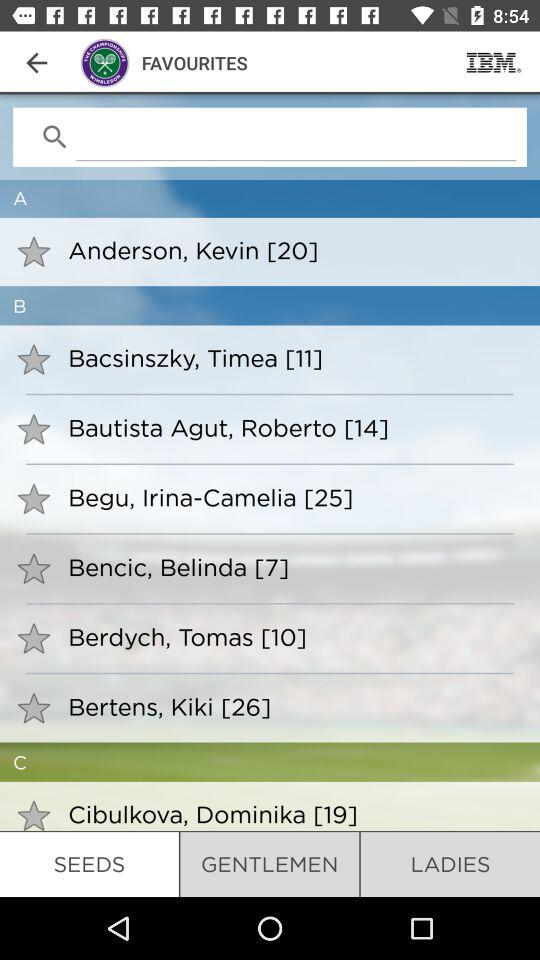Which tab is selected? The tab "SEEDS" is selected. 